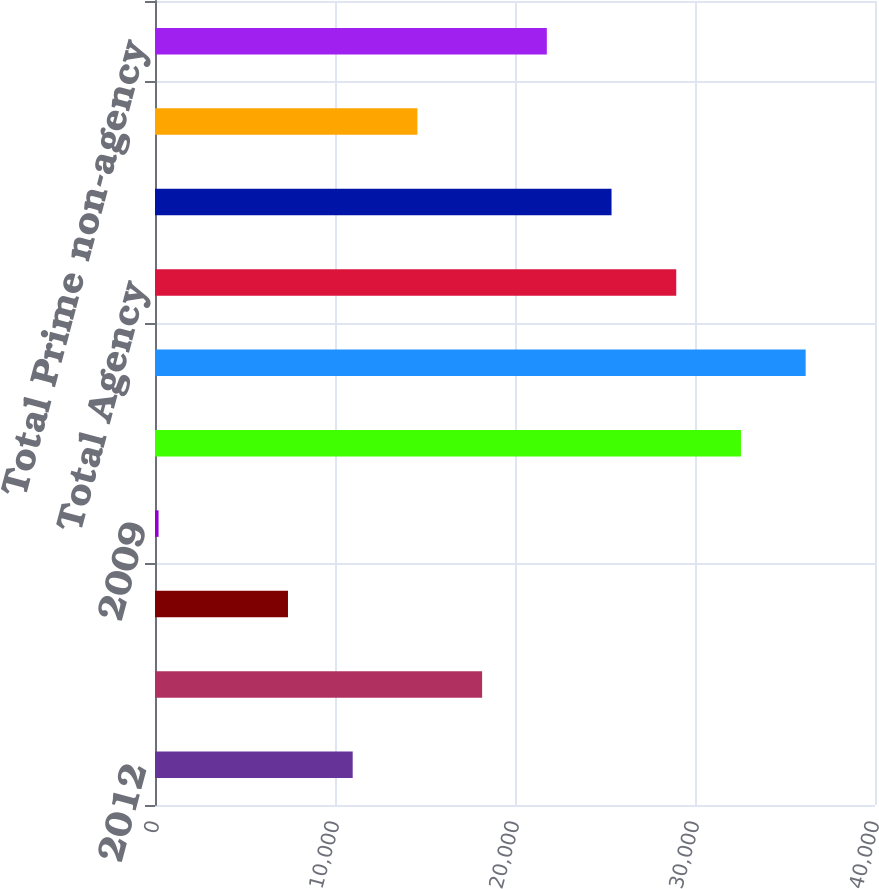<chart> <loc_0><loc_0><loc_500><loc_500><bar_chart><fcel>2012<fcel>2011<fcel>2010<fcel>2009<fcel>2008 and prior<fcel>Total RMBS<fcel>Total Agency<fcel>Total Alt-A<fcel>Total Subprime<fcel>Total Prime non-agency<nl><fcel>10983<fcel>18173<fcel>7388<fcel>198<fcel>32553<fcel>36148<fcel>28958<fcel>25363<fcel>14578<fcel>21768<nl></chart> 